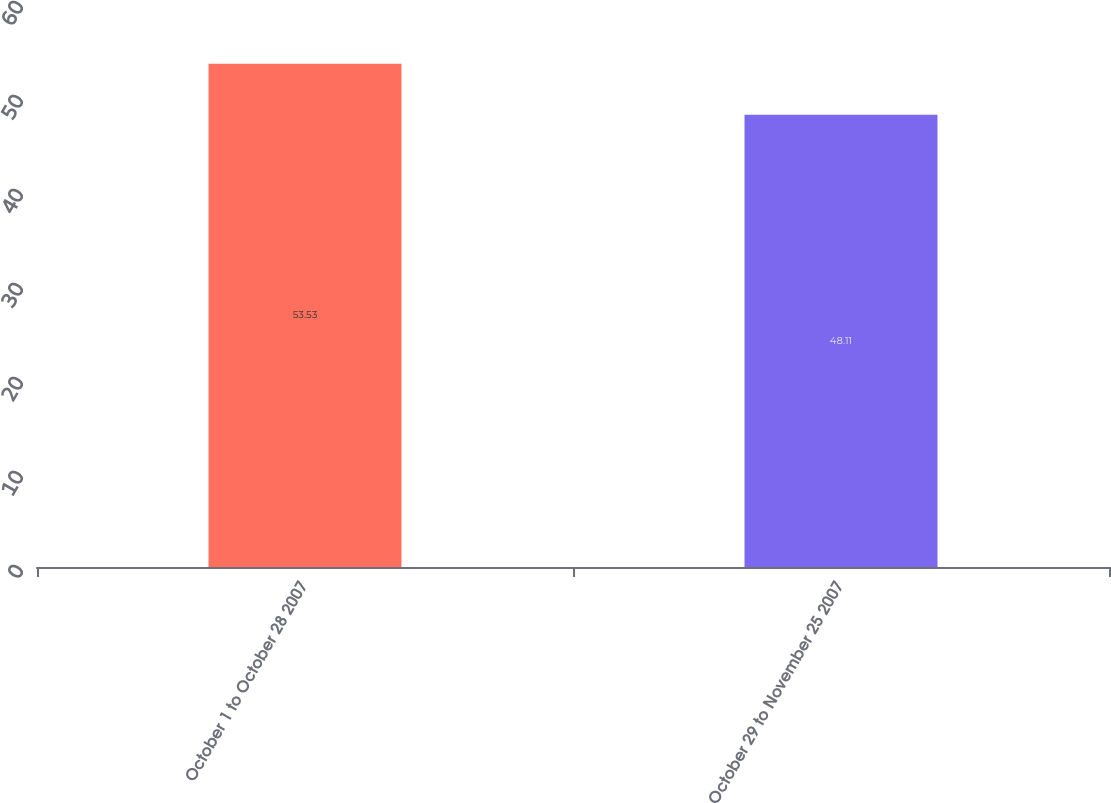<chart> <loc_0><loc_0><loc_500><loc_500><bar_chart><fcel>October 1 to October 28 2007<fcel>October 29 to November 25 2007<nl><fcel>53.53<fcel>48.11<nl></chart> 